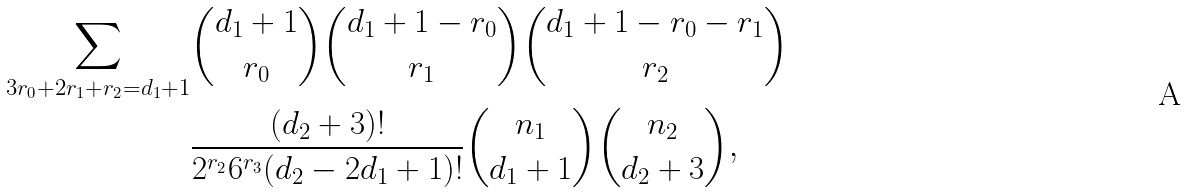<formula> <loc_0><loc_0><loc_500><loc_500>\sum _ { 3 r _ { 0 } + 2 r _ { 1 } + r _ { 2 } = d _ { 1 } + 1 } & { d _ { 1 } + 1 \choose r _ { 0 } } { d _ { 1 } + 1 - r _ { 0 } \choose r _ { 1 } } { d _ { 1 } + 1 - r _ { 0 } - r _ { 1 } \choose r _ { 2 } } \\ & \frac { ( d _ { 2 } + 3 ) ! } { 2 ^ { r _ { 2 } } 6 ^ { r _ { 3 } } ( d _ { 2 } - 2 d _ { 1 } + 1 ) ! } { n _ { 1 } \choose d _ { 1 } + 1 } { n _ { 2 } \choose d _ { 2 } + 3 } ,</formula> 